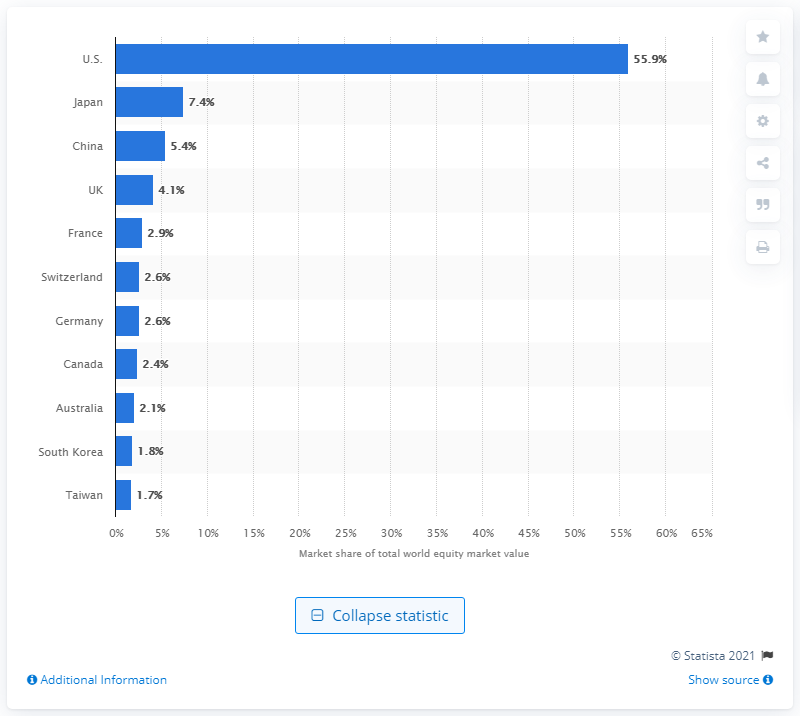Mention a couple of crucial points in this snapshot. In 2021, it was estimated that 55.9% of world stocks were held by stock markets in the United States. Japan is the second largest country by stock market share. At the time of the largest country by stock market share, it was China. 